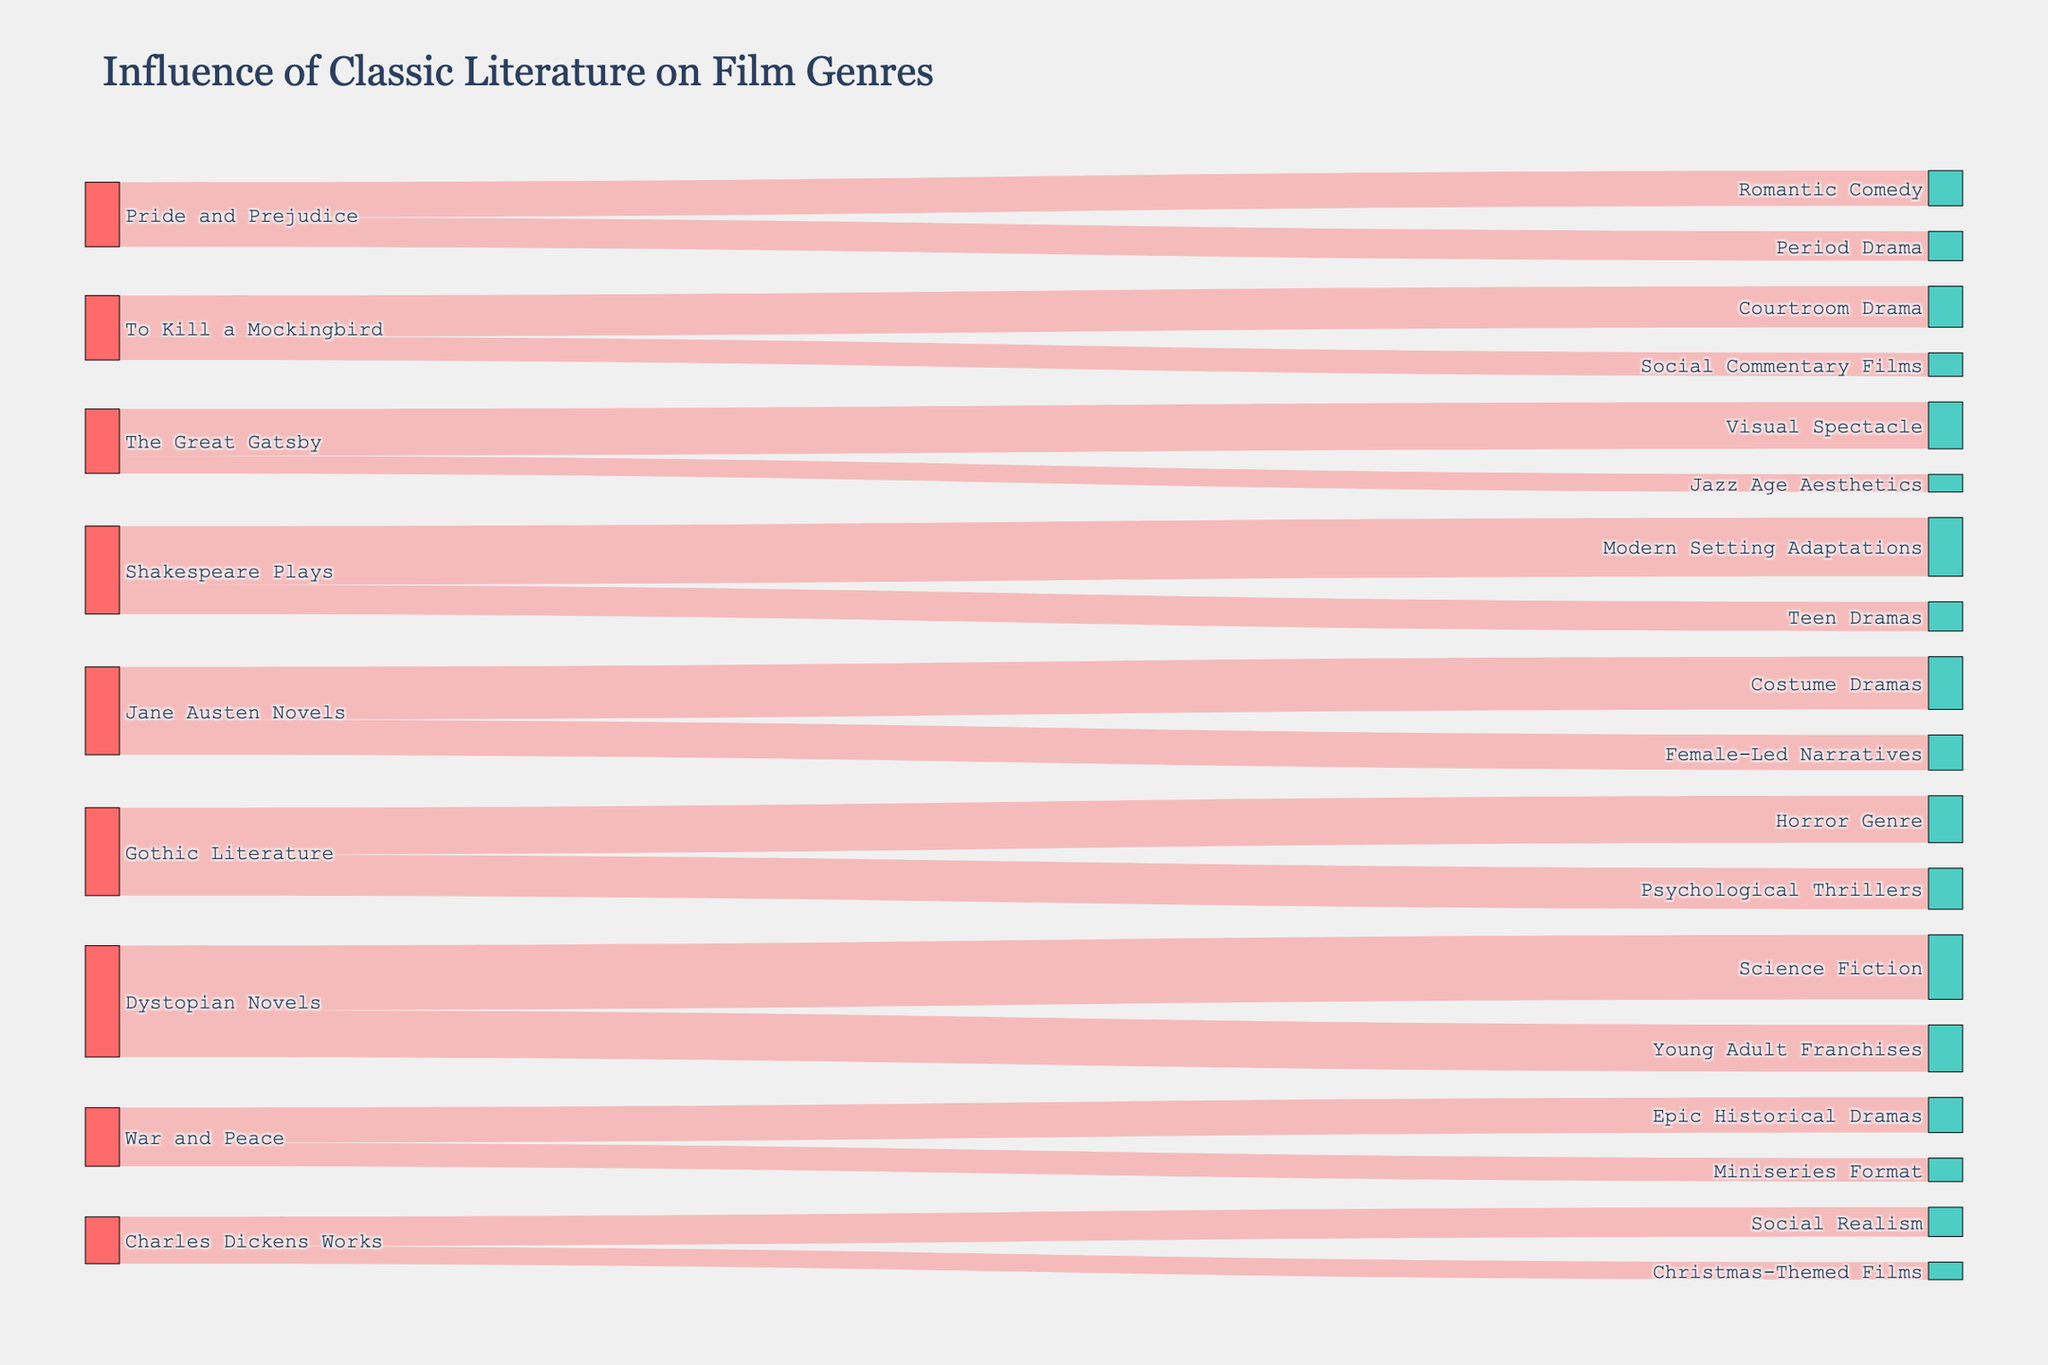Which classic literature adaptation has the strongest influence on the Romantic Comedy film genre? Look for the source node connected to the 'Romantic Comedy' target with the highest value. Pride and Prejudice is the only source node linked to Romantic Comedy with a value of 30.
Answer: Pride and Prejudice What is the total influence value of Jane Austen Novels on subsequent film genres? Add the values of all target nodes connected to the 'Jane Austen Novels' source node. The values are Costume Dramas (45) and Female-Led Narratives (30). So, the total is 45 + 30.
Answer: 75 Which genre does Gothic Literature influence more, Horror Genre or Psychological Thrillers? Compare the values of the links from 'Gothic Literature' to 'Horror Genre' and 'Psychological Thrillers'. Horror Genre is influenced by 40, while Psychological Thrillers is influenced by 35.
Answer: Horror Genre How does the influence of Charles Dickens Works on Christmas-Themed Films compare to Social Realism? Compare the values of the links from 'Charles Dickens Works' to 'Christmas-Themed Films' and 'Social Realism'. Social Realism has an influence value of 25, while Christmas-Themed Films have an influence value of 15.
Answer: Social Realism has a higher influence What theme does The Great Gatsby contribute most to in subsequent films? Look for the target node connected to 'The Great Gatsby' with the highest value. Visual Spectacle has a value of 40, while Jazz Age Aesthetics has 15.
Answer: Visual Spectacle How many film genres and styles are represented in the diagram? Count the number of unique target nodes. There are 14 unique genres and styles.
Answer: 14 What’s the average influence value of Dystopian Novels on film genres? Add the values of the links from 'Dystopian Novels' to all its connected genres and divide by the number of target genres. The values are 55 (Science Fiction) and 40 (Young Adult Franchises). (55 + 40) / 2 = 47.5.
Answer: 47.5 Which classic literature source influences the most number of film genres? Look for the source node with the highest number of direct links to unique target nodes. Shakespeare Plays influences two genres: Modern Setting Adaptations and Teen Dramas.
Answer: Shakespeare Plays (2) What is the combined value of all influences by War and Peace? Sum up the values of the two film genres influenced by War and Peace. The values are 30 (Epic Historical Dramas) and 20 (Miniseries Format). 30 + 20 = 50.
Answer: 50 Which genre, influenced by To Kill a Mockingbird, deals more with societal themes? Compare the nature of the genres. Courtroom Drama is specific to legal settings, while Social Commentary Films specifically deal with societal themes.
Answer: Social Commentary Films 